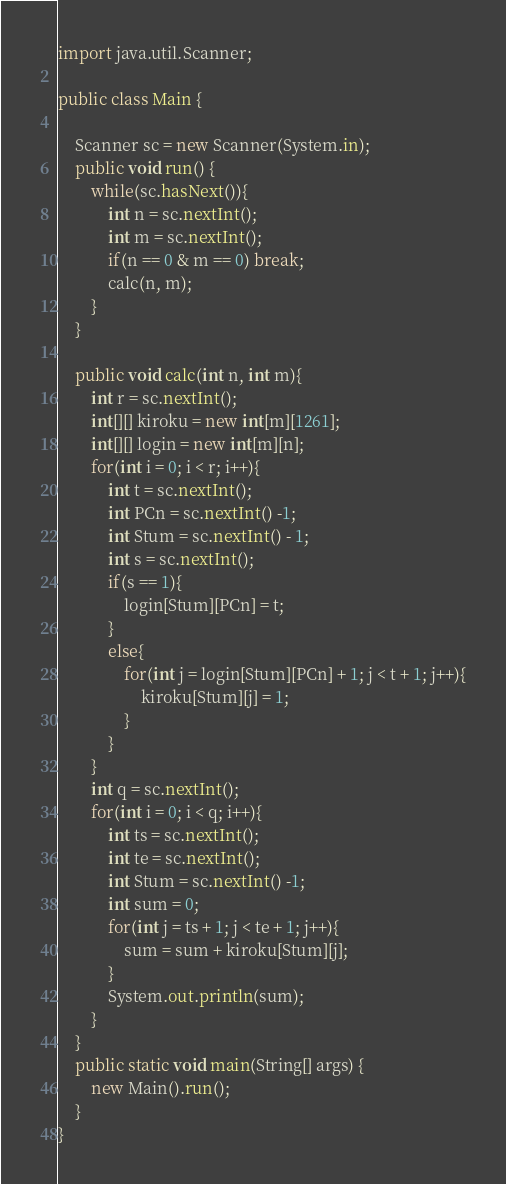Convert code to text. <code><loc_0><loc_0><loc_500><loc_500><_Java_>import java.util.Scanner;

public class Main {

	Scanner sc = new Scanner(System.in);
	public void run() {
		while(sc.hasNext()){
			int n = sc.nextInt();
			int m = sc.nextInt();
			if(n == 0 & m == 0) break;
			calc(n, m);
		}
	}

	public void calc(int n, int m){
		int r = sc.nextInt();
		int[][] kiroku = new int[m][1261];
		int[][] login = new int[m][n];
		for(int i = 0; i < r; i++){
			int t = sc.nextInt();
			int PCn = sc.nextInt() -1;
			int Stum = sc.nextInt() - 1;
			int s = sc.nextInt();
			if(s == 1){
				login[Stum][PCn] = t;
			}
			else{
				for(int j = login[Stum][PCn] + 1; j < t + 1; j++){
					kiroku[Stum][j] = 1;
				}
			}
		}
		int q = sc.nextInt();
		for(int i = 0; i < q; i++){
			int ts = sc.nextInt();
			int te = sc.nextInt();
			int Stum = sc.nextInt() -1;
			int sum = 0;
			for(int j = ts + 1; j < te + 1; j++){
				sum = sum + kiroku[Stum][j];
			}
			System.out.println(sum);
		}
	}
	public static void main(String[] args) {
		new Main().run();
	}
}</code> 